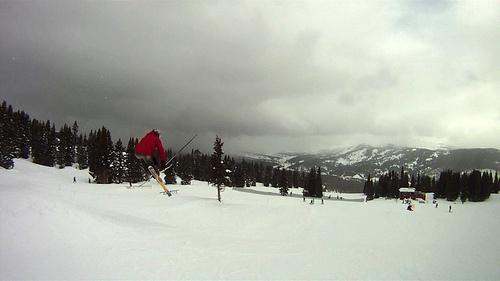Describe the objects in this image and their specific colors. I can see people in gray, black, beige, and darkgray tones, people in gray, maroon, and black tones, skis in gray, tan, and olive tones, skis in gray, darkgray, black, and lightgray tones, and people in gray, beige, and darkgray tones in this image. 